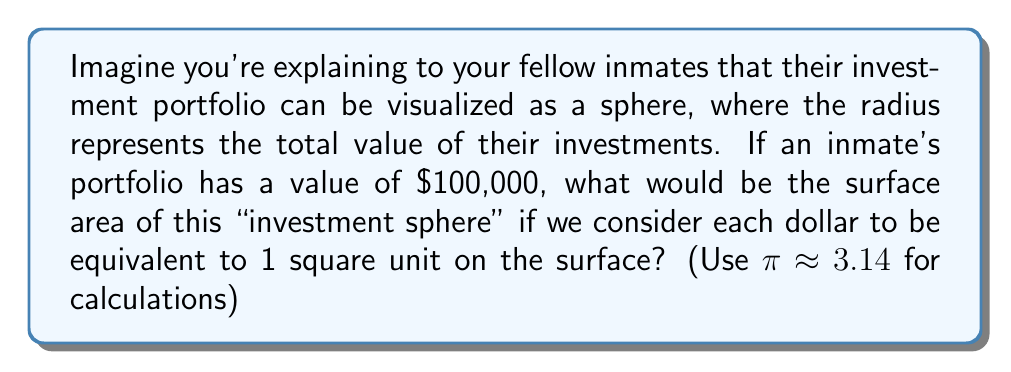Provide a solution to this math problem. Let's approach this step-by-step:

1) In this analogy, we're treating the investment portfolio as a sphere, where:
   - The radius $r$ of the sphere represents the total value of the portfolio
   - Each dollar is equivalent to 1 square unit on the surface

2) Given:
   - Portfolio value = $100,000 = r$
   - $\pi \approx 3.14$

3) The formula for the surface area of a sphere is:
   $$ A = 4\pi r^2 $$

4) Substituting our values:
   $$ A = 4 \cdot 3.14 \cdot (100,000)^2 $$

5) Simplify:
   $$ A = 12.56 \cdot (10,000,000,000) $$
   $$ A = 125,600,000,000 $$

6) Therefore, the surface area of the "investment sphere" is 125,600,000,000 square units.

This large number represents the potential "exposure" or "reach" of the investment across various markets and opportunities, illustrating to the inmates how even a modest investment can have a significant presence in the financial world.
Answer: 125,600,000,000 square units 